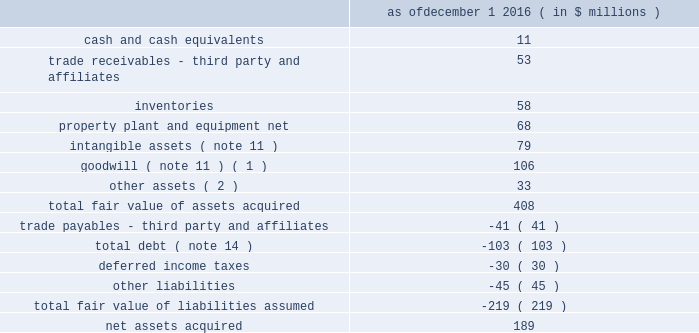Table of contents 4 .
Acquisitions , dispositions and plant closures acquisitions 2022 so.f.ter .
S.p.a .
On december 1 , 2016 , the company acquired 100% ( 100 % ) of the stock of the forli , italy based so.f.ter .
S.p.a .
( "softer" ) , a leading thermoplastic compounder .
The acquisition of softer increases the company's global engineered materials product platforms , extends the operational model , technical and industry solutions capabilities and expands project pipelines .
The acquisition was accounted for as a business combination and the acquired operations are included in the advanced engineered materials segment .
Pro forma financial information since the respective acquisition date has not been provided as the acquisition did not have a material impact on the company's financial information .
The company allocated the purchase price of the acquisition to identifiable assets acquired and liabilities assumed based on their estimated fair values as of the acquisition date .
The excess of the purchase price over the aggregate fair values was recorded as goodwill ( note 2 and note 11 ) .
The company calculated the fair value of the assets acquired using the income , market , or cost approach ( or a combination thereof ) .
Fair values were determined based on level 3 inputs ( note 2 ) including estimated future cash flows , discount rates , royalty rates , growth rates , sales projections , retention rates and terminal values , all of which require significant management judgment and are susceptible to change .
The purchase price allocation is based upon preliminary information and is subject to change if additional information about the facts and circumstances that existed at the acquisition date becomes available .
The final fair value of the net assets acquired may result in adjustments to the assets and liabilities , including goodwill .
However , any subsequent measurement period adjustments are not expected to have a material impact on the company's results of operations .
The preliminary purchase price allocation for the softer acquisition is as follows : december 1 , 2016 ( in $ millions ) .
______________________________ ( 1 ) goodwill consists of expected revenue and operating synergies resulting from the acquisition .
None of the goodwill is deductible for income tax purposes .
( 2 ) includes a $ 23 million indemnity receivable for uncertain tax positions related to the acquisition .
Transaction related costs of $ 3 million were expensed as incurred to selling , general and administrative expenses in the consolidated statements of operations .
The amount of pro forma net earnings ( loss ) of softer included in the company's consolidated statement of operations was approximately 2% ( 2 % ) ( unaudited ) of its consolidated net earnings ( loss ) had the acquisition occurred as of the beginning of 2016 .
The amount of softer net earnings ( loss ) consolidated by the company since the acquisition date was not material. .
How much of the softer assets acquired were hard assets? 
Rationale: ppe - hard assets
Computations: (68 / 408)
Answer: 0.16667. 